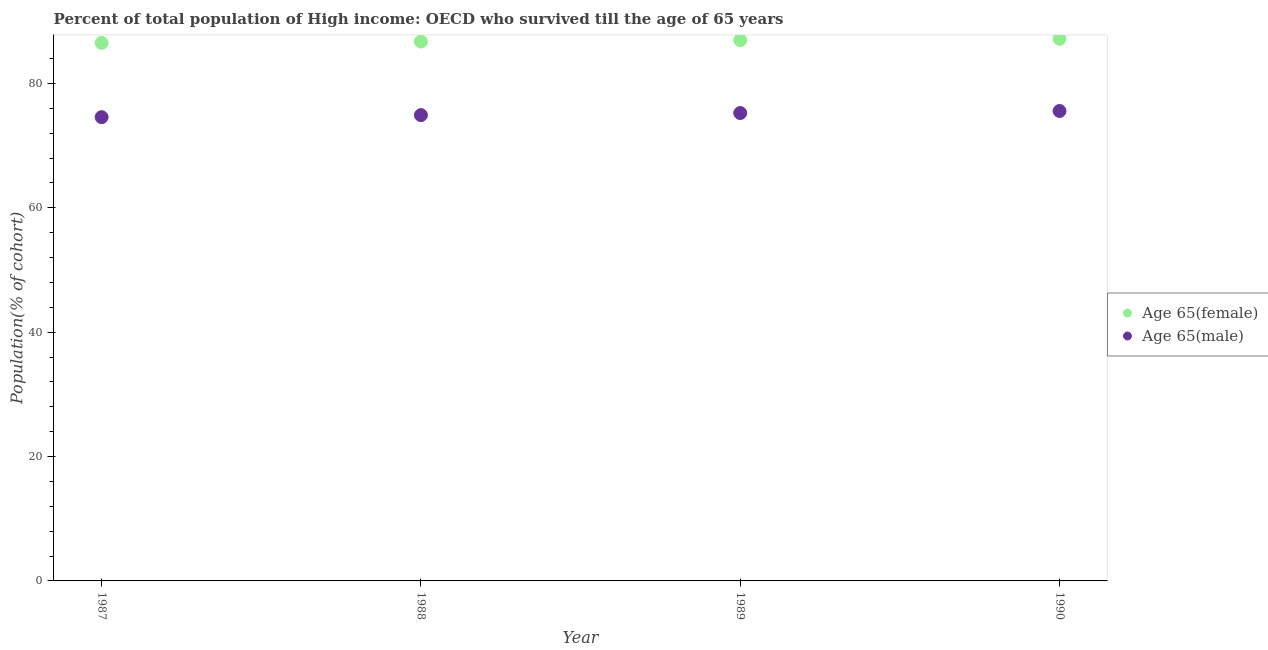Is the number of dotlines equal to the number of legend labels?
Give a very brief answer. Yes. What is the percentage of female population who survived till age of 65 in 1987?
Ensure brevity in your answer.  86.51. Across all years, what is the maximum percentage of female population who survived till age of 65?
Provide a succinct answer. 87.17. Across all years, what is the minimum percentage of female population who survived till age of 65?
Give a very brief answer. 86.51. In which year was the percentage of female population who survived till age of 65 maximum?
Offer a terse response. 1990. What is the total percentage of female population who survived till age of 65 in the graph?
Keep it short and to the point. 347.36. What is the difference between the percentage of female population who survived till age of 65 in 1987 and that in 1988?
Offer a terse response. -0.22. What is the difference between the percentage of male population who survived till age of 65 in 1987 and the percentage of female population who survived till age of 65 in 1988?
Provide a succinct answer. -12.16. What is the average percentage of male population who survived till age of 65 per year?
Give a very brief answer. 75.06. In the year 1988, what is the difference between the percentage of male population who survived till age of 65 and percentage of female population who survived till age of 65?
Your answer should be very brief. -11.83. In how many years, is the percentage of male population who survived till age of 65 greater than 80 %?
Your answer should be compact. 0. What is the ratio of the percentage of female population who survived till age of 65 in 1989 to that in 1990?
Your answer should be compact. 1. What is the difference between the highest and the second highest percentage of male population who survived till age of 65?
Provide a short and direct response. 0.33. What is the difference between the highest and the lowest percentage of male population who survived till age of 65?
Ensure brevity in your answer.  0.99. Is the sum of the percentage of female population who survived till age of 65 in 1988 and 1990 greater than the maximum percentage of male population who survived till age of 65 across all years?
Provide a short and direct response. Yes. Is the percentage of female population who survived till age of 65 strictly greater than the percentage of male population who survived till age of 65 over the years?
Give a very brief answer. Yes. How many years are there in the graph?
Make the answer very short. 4. Are the values on the major ticks of Y-axis written in scientific E-notation?
Your response must be concise. No. Does the graph contain any zero values?
Offer a terse response. No. Where does the legend appear in the graph?
Offer a terse response. Center right. How many legend labels are there?
Ensure brevity in your answer.  2. How are the legend labels stacked?
Your answer should be compact. Vertical. What is the title of the graph?
Make the answer very short. Percent of total population of High income: OECD who survived till the age of 65 years. What is the label or title of the X-axis?
Give a very brief answer. Year. What is the label or title of the Y-axis?
Your answer should be very brief. Population(% of cohort). What is the Population(% of cohort) of Age 65(female) in 1987?
Make the answer very short. 86.51. What is the Population(% of cohort) of Age 65(male) in 1987?
Your answer should be compact. 74.57. What is the Population(% of cohort) of Age 65(female) in 1988?
Provide a succinct answer. 86.73. What is the Population(% of cohort) of Age 65(male) in 1988?
Provide a succinct answer. 74.9. What is the Population(% of cohort) in Age 65(female) in 1989?
Provide a short and direct response. 86.95. What is the Population(% of cohort) of Age 65(male) in 1989?
Your answer should be compact. 75.23. What is the Population(% of cohort) in Age 65(female) in 1990?
Offer a very short reply. 87.17. What is the Population(% of cohort) of Age 65(male) in 1990?
Make the answer very short. 75.56. Across all years, what is the maximum Population(% of cohort) of Age 65(female)?
Offer a terse response. 87.17. Across all years, what is the maximum Population(% of cohort) of Age 65(male)?
Offer a very short reply. 75.56. Across all years, what is the minimum Population(% of cohort) of Age 65(female)?
Offer a terse response. 86.51. Across all years, what is the minimum Population(% of cohort) in Age 65(male)?
Keep it short and to the point. 74.57. What is the total Population(% of cohort) of Age 65(female) in the graph?
Offer a terse response. 347.36. What is the total Population(% of cohort) in Age 65(male) in the graph?
Provide a succinct answer. 300.26. What is the difference between the Population(% of cohort) in Age 65(female) in 1987 and that in 1988?
Make the answer very short. -0.22. What is the difference between the Population(% of cohort) of Age 65(male) in 1987 and that in 1988?
Ensure brevity in your answer.  -0.33. What is the difference between the Population(% of cohort) in Age 65(female) in 1987 and that in 1989?
Provide a short and direct response. -0.44. What is the difference between the Population(% of cohort) in Age 65(male) in 1987 and that in 1989?
Keep it short and to the point. -0.66. What is the difference between the Population(% of cohort) of Age 65(female) in 1987 and that in 1990?
Your response must be concise. -0.66. What is the difference between the Population(% of cohort) of Age 65(male) in 1987 and that in 1990?
Your answer should be very brief. -0.99. What is the difference between the Population(% of cohort) of Age 65(female) in 1988 and that in 1989?
Ensure brevity in your answer.  -0.22. What is the difference between the Population(% of cohort) in Age 65(male) in 1988 and that in 1989?
Your answer should be compact. -0.33. What is the difference between the Population(% of cohort) of Age 65(female) in 1988 and that in 1990?
Offer a terse response. -0.44. What is the difference between the Population(% of cohort) in Age 65(male) in 1988 and that in 1990?
Your answer should be very brief. -0.66. What is the difference between the Population(% of cohort) of Age 65(female) in 1989 and that in 1990?
Your answer should be very brief. -0.22. What is the difference between the Population(% of cohort) in Age 65(male) in 1989 and that in 1990?
Give a very brief answer. -0.33. What is the difference between the Population(% of cohort) in Age 65(female) in 1987 and the Population(% of cohort) in Age 65(male) in 1988?
Give a very brief answer. 11.61. What is the difference between the Population(% of cohort) in Age 65(female) in 1987 and the Population(% of cohort) in Age 65(male) in 1989?
Keep it short and to the point. 11.28. What is the difference between the Population(% of cohort) of Age 65(female) in 1987 and the Population(% of cohort) of Age 65(male) in 1990?
Make the answer very short. 10.95. What is the difference between the Population(% of cohort) in Age 65(female) in 1988 and the Population(% of cohort) in Age 65(male) in 1989?
Your answer should be compact. 11.5. What is the difference between the Population(% of cohort) of Age 65(female) in 1988 and the Population(% of cohort) of Age 65(male) in 1990?
Your response must be concise. 11.17. What is the difference between the Population(% of cohort) in Age 65(female) in 1989 and the Population(% of cohort) in Age 65(male) in 1990?
Ensure brevity in your answer.  11.39. What is the average Population(% of cohort) in Age 65(female) per year?
Ensure brevity in your answer.  86.84. What is the average Population(% of cohort) of Age 65(male) per year?
Keep it short and to the point. 75.06. In the year 1987, what is the difference between the Population(% of cohort) of Age 65(female) and Population(% of cohort) of Age 65(male)?
Provide a short and direct response. 11.94. In the year 1988, what is the difference between the Population(% of cohort) of Age 65(female) and Population(% of cohort) of Age 65(male)?
Offer a terse response. 11.83. In the year 1989, what is the difference between the Population(% of cohort) of Age 65(female) and Population(% of cohort) of Age 65(male)?
Make the answer very short. 11.72. In the year 1990, what is the difference between the Population(% of cohort) in Age 65(female) and Population(% of cohort) in Age 65(male)?
Your answer should be very brief. 11.61. What is the ratio of the Population(% of cohort) of Age 65(female) in 1987 to that in 1988?
Your answer should be compact. 1. What is the ratio of the Population(% of cohort) in Age 65(male) in 1987 to that in 1988?
Offer a very short reply. 1. What is the ratio of the Population(% of cohort) in Age 65(male) in 1987 to that in 1989?
Keep it short and to the point. 0.99. What is the ratio of the Population(% of cohort) in Age 65(female) in 1987 to that in 1990?
Give a very brief answer. 0.99. What is the ratio of the Population(% of cohort) of Age 65(male) in 1987 to that in 1990?
Keep it short and to the point. 0.99. What is the ratio of the Population(% of cohort) of Age 65(male) in 1988 to that in 1989?
Provide a succinct answer. 1. What is the ratio of the Population(% of cohort) in Age 65(male) in 1989 to that in 1990?
Give a very brief answer. 1. What is the difference between the highest and the second highest Population(% of cohort) of Age 65(female)?
Give a very brief answer. 0.22. What is the difference between the highest and the second highest Population(% of cohort) in Age 65(male)?
Offer a terse response. 0.33. What is the difference between the highest and the lowest Population(% of cohort) in Age 65(female)?
Offer a very short reply. 0.66. What is the difference between the highest and the lowest Population(% of cohort) of Age 65(male)?
Offer a very short reply. 0.99. 